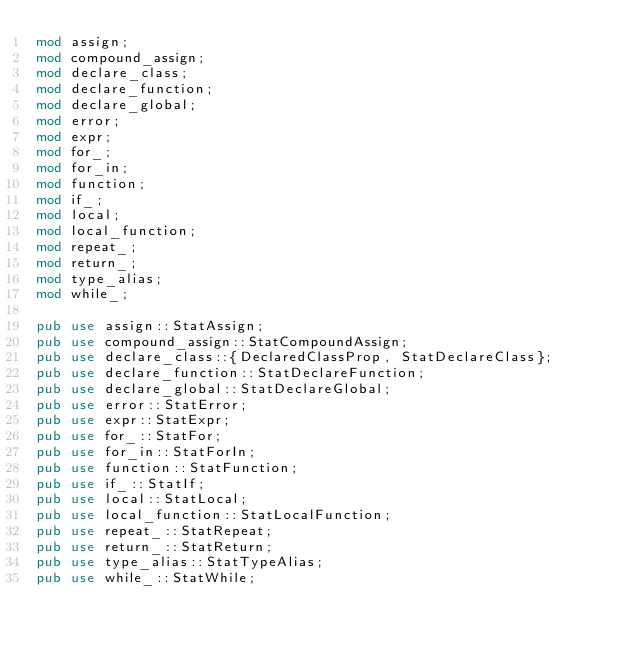Convert code to text. <code><loc_0><loc_0><loc_500><loc_500><_Rust_>mod assign;
mod compound_assign;
mod declare_class;
mod declare_function;
mod declare_global;
mod error;
mod expr;
mod for_;
mod for_in;
mod function;
mod if_;
mod local;
mod local_function;
mod repeat_;
mod return_;
mod type_alias;
mod while_;

pub use assign::StatAssign;
pub use compound_assign::StatCompoundAssign;
pub use declare_class::{DeclaredClassProp, StatDeclareClass};
pub use declare_function::StatDeclareFunction;
pub use declare_global::StatDeclareGlobal;
pub use error::StatError;
pub use expr::StatExpr;
pub use for_::StatFor;
pub use for_in::StatForIn;
pub use function::StatFunction;
pub use if_::StatIf;
pub use local::StatLocal;
pub use local_function::StatLocalFunction;
pub use repeat_::StatRepeat;
pub use return_::StatReturn;
pub use type_alias::StatTypeAlias;
pub use while_::StatWhile;
</code> 